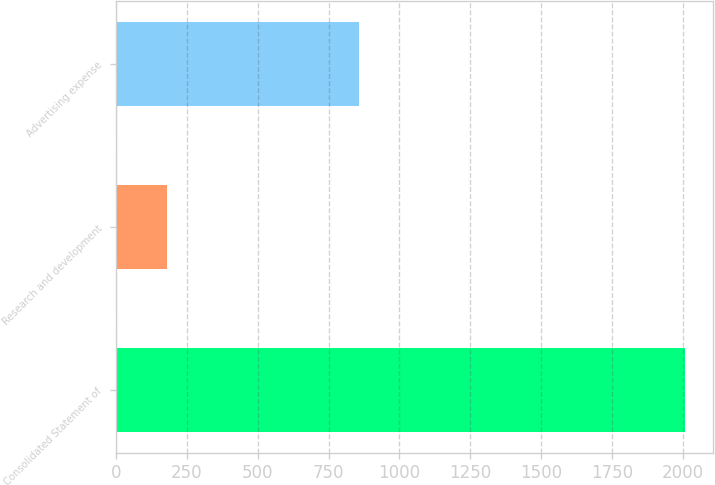Convert chart. <chart><loc_0><loc_0><loc_500><loc_500><bar_chart><fcel>Consolidated Statement of<fcel>Research and development<fcel>Advertising expense<nl><fcel>2005<fcel>181<fcel>857.7<nl></chart> 